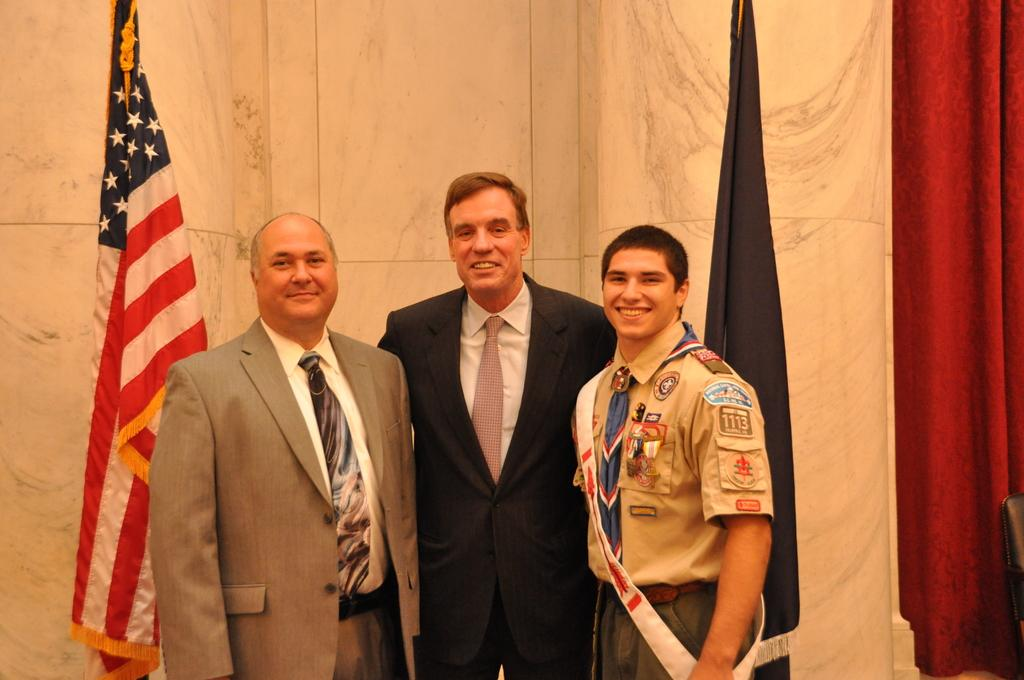What is the setting of the image? The image is of a room. How many people are in the room? There are three persons standing in the room. What is the mood of the people in the image? The persons are smiling, which suggests a positive mood. What decorative elements are present in the room? There are flags at the back of the room and a red curtain. What type of furniture is in the room? There is a chair in the room. What type of sack is being used by the band in the image? There is no band or sack present in the image; it features three smiling persons in a room with flags, a red curtain, and a chair. 